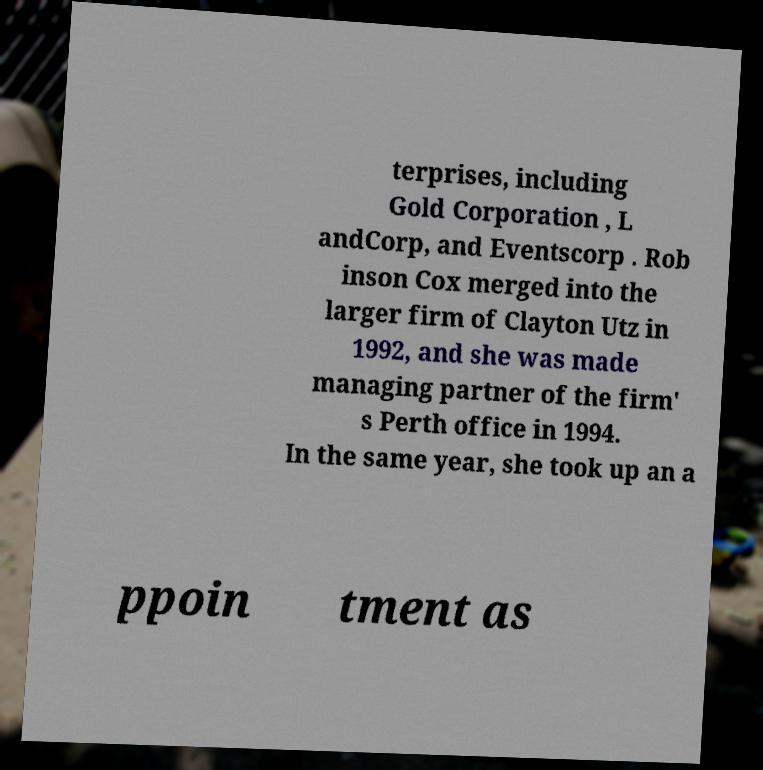Could you assist in decoding the text presented in this image and type it out clearly? terprises, including Gold Corporation , L andCorp, and Eventscorp . Rob inson Cox merged into the larger firm of Clayton Utz in 1992, and she was made managing partner of the firm' s Perth office in 1994. In the same year, she took up an a ppoin tment as 